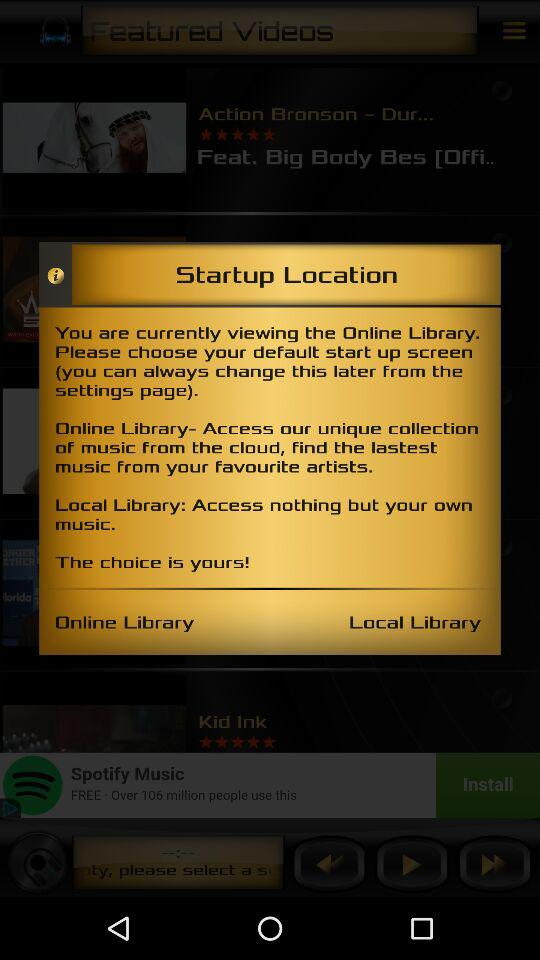How many different types of libraries are available?
Answer the question using a single word or phrase. 2 